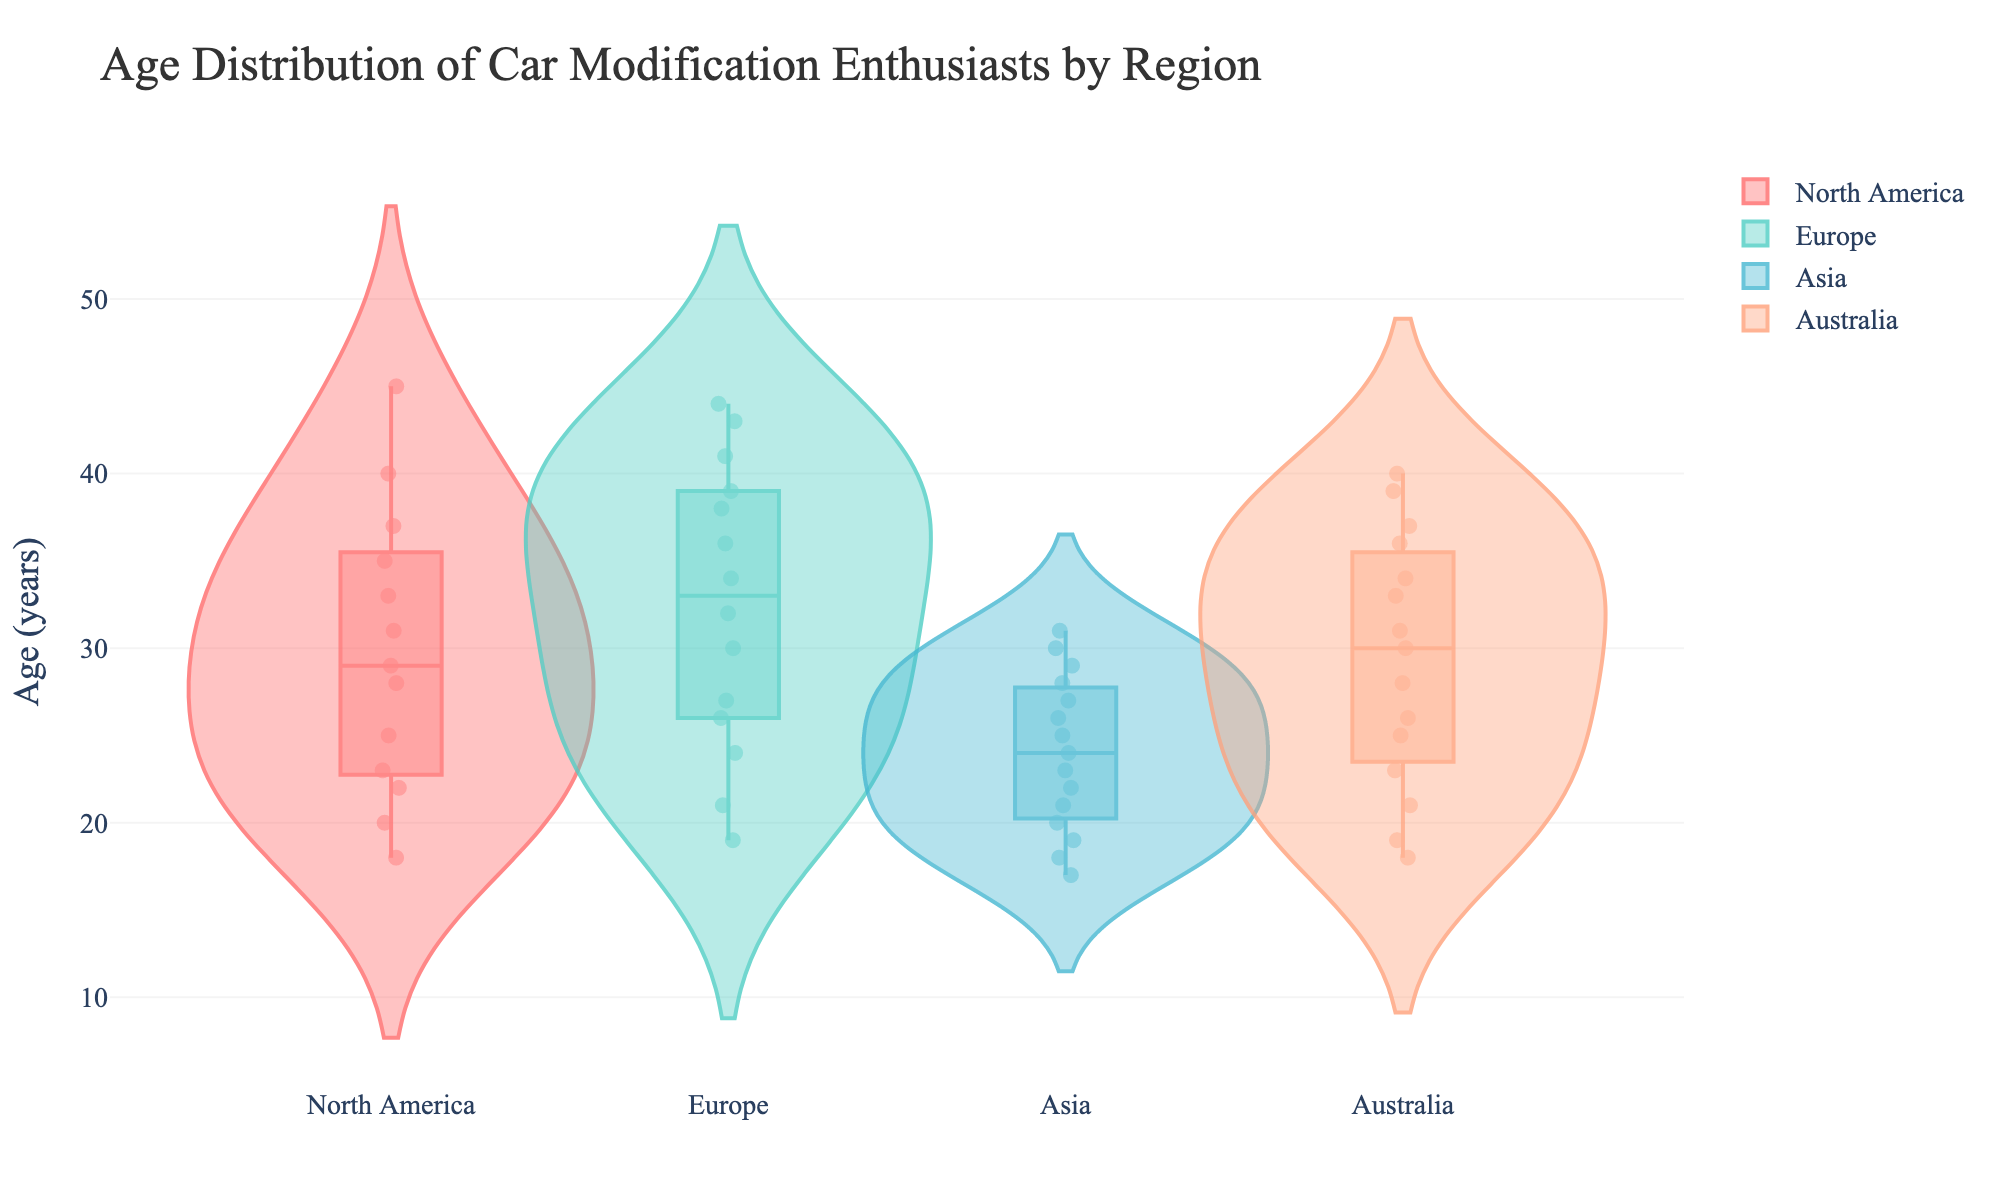What is the title of the chart? The title of the chart is displayed at the top and provides a summary of what the figure represents, which is "Age Distribution of Car Modification Enthusiasts by Region".
Answer: Age Distribution of Car Modification Enthusiasts by Region Which region has the widest age range of car modification enthusiasts? Look at the length of the violins. The region with the most extended violin plot indicates the widest age range.
Answer: North America What is the median age of car modification enthusiasts in Asia? The median age can be identified by the horizontal line within the box in the violin plot for Asia.
Answer: 23 Which region has the youngest car modification enthusiasts on average? Identify the regions and look for the violin plot section closer to the lower end of the age axis. Asia shows lower ages on average.
Answer: Asia Which region has car modification enthusiasts with the highest age? The top part of the violin plots shows the highest ages recorded. North America and Europe both have ages extending to higher values, but North America has car enthusiasts up to an age of approximately 45.
Answer: North America What is the interquartile range (IQR) of ages in Europe? The IQR can be calculated by looking at the box boundaries within the violin plot for Europe, representing the 25th and 75th percentiles. Subtract the lower quartile from the upper quartile.
Answer: 14 (41 - 27) How does the age distribution in Australia compare to that in Europe? Compare the shape, spread, and central measures (e.g., median) of the violin plots for Australia and Europe. The plots suggest that both regions have similar median ages, but Europe's distribution extends to slightly younger ages and is narrower.
Answer: Similar median, Europe's distribution starts younger Which region shows the most symmetrical age distribution? Symmetry in the violin plot indicates a similar spread of ages around the median. Identifying the region with the most balanced upper and lower parts.
Answer: Europe In which region are the most data points concentrated around the median age? Look for the violin plot that is the widest nearest the central line (median). The region with the widest center indicates more data points concentrated around the median.
Answer: Asia Are there outliers in any region? If yes, which region has the most significant outliers? Outliers are often represented by individual points outside the main bulk of the data. Determine which region has more data points away from the main viable range.
Answer: No significant outliers detected 